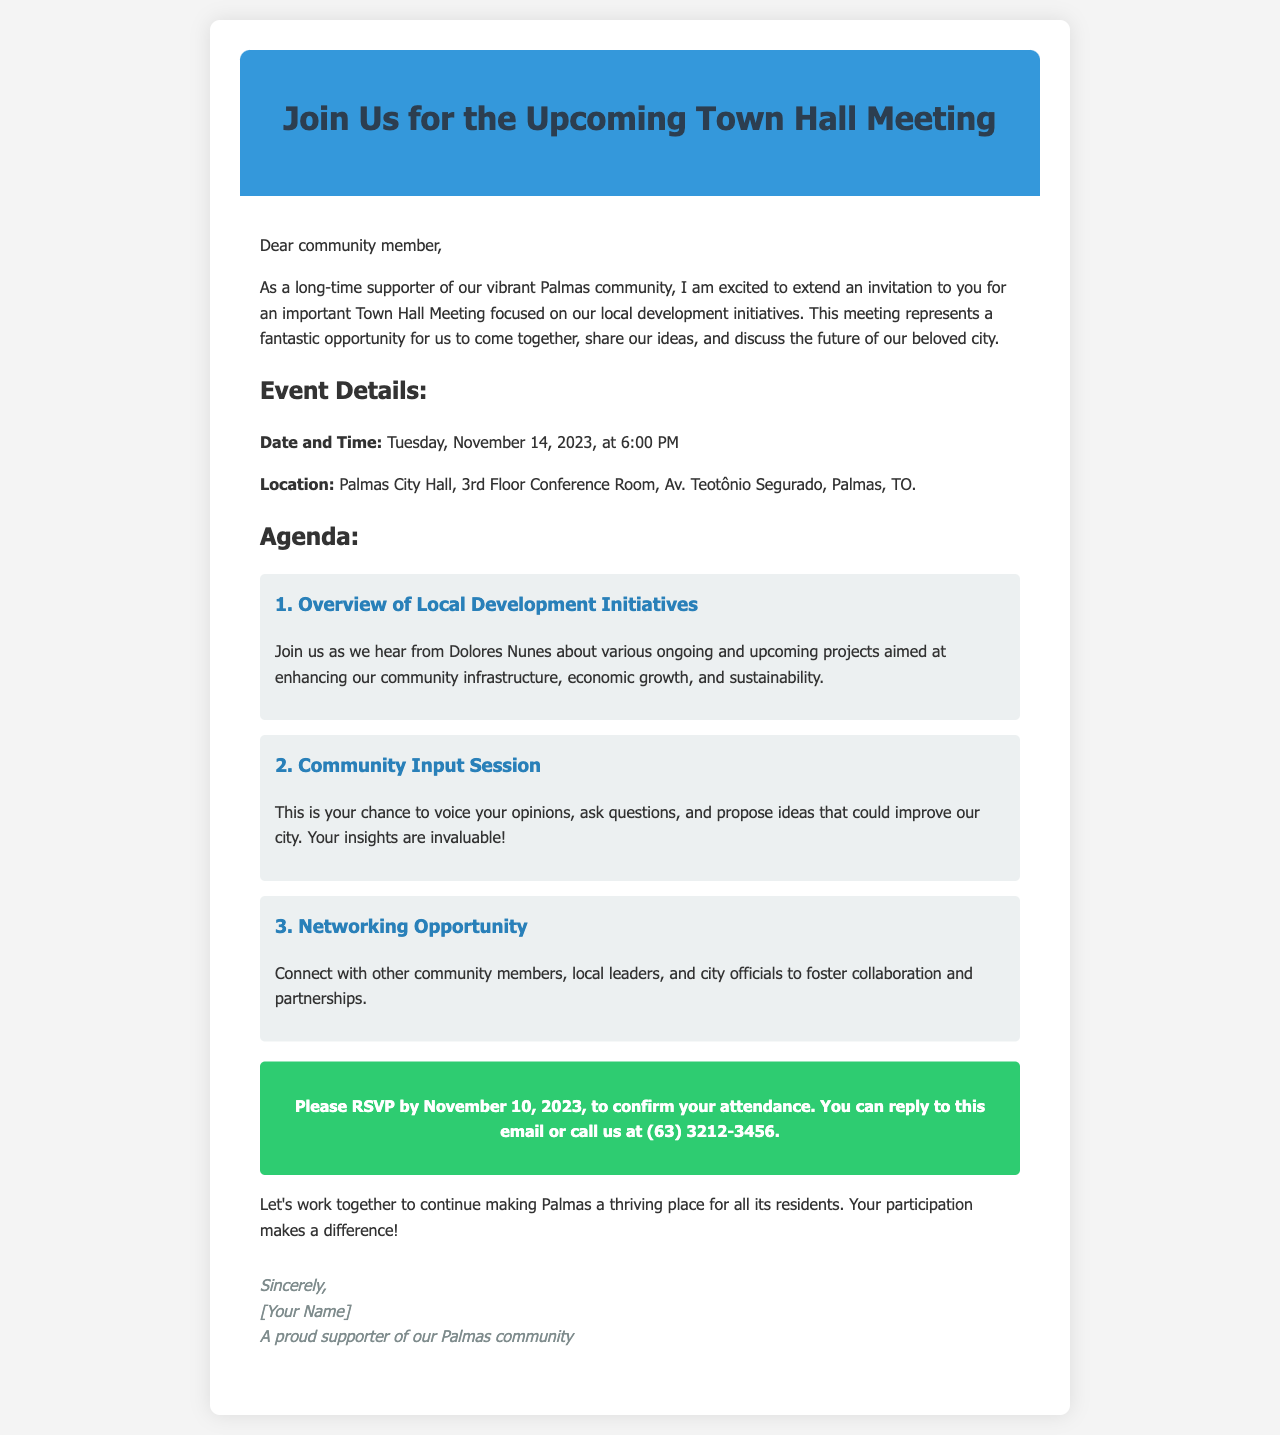what is the date of the Town Hall Meeting? The date mentioned in the document for the Town Hall Meeting is specified as Tuesday, November 14, 2023.
Answer: Tuesday, November 14, 2023 where will the meeting take place? The location of the Town Hall Meeting is stated as Palmas City Hall, 3rd Floor Conference Room, Av. Teotônio Segurado, Palmas, TO.
Answer: Palmas City Hall, 3rd Floor Conference Room, Av. Teotônio Segurado, Palmas, TO who will present the overview of local development initiatives? The document indicates that Dolores Nunes will be presenting the overview.
Answer: Dolores Nunes when is the RSVP deadline? The deadline for RSVPing to confirm attendance is mentioned as November 10, 2023.
Answer: November 10, 2023 how many agenda items are listed? The document lists three agenda items for the Town Hall Meeting.
Answer: Three what is the purpose of the Community Input Session? The purpose of the Community Input Session is stated as a chance for attendees to voice opinions and propose ideas.
Answer: Voice opinions and propose ideas what is the main goal of the event? The main goal of the event is to discuss local development initiatives and enhance the community.
Answer: Discuss local development initiatives how can attendees RSVP? The method for RSVPing to the event is provided as either replying to the email or calling a phone number.
Answer: Replying to the email or calling us at (63) 3212-3456 